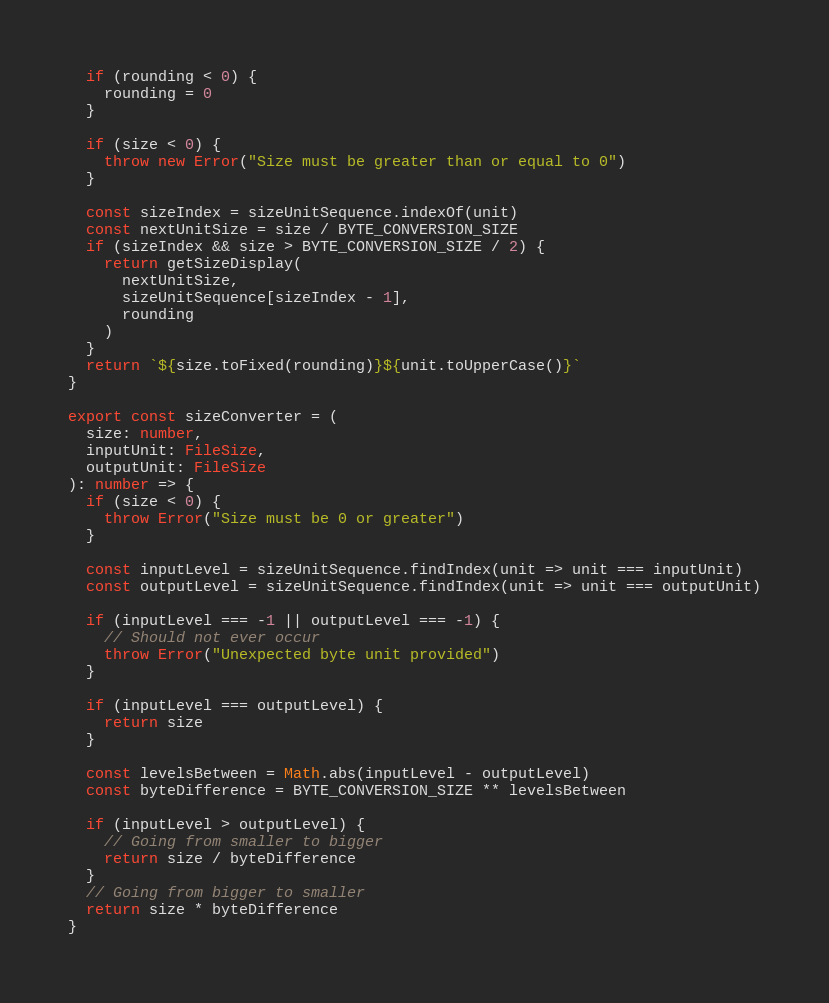<code> <loc_0><loc_0><loc_500><loc_500><_TypeScript_>
  if (rounding < 0) {
    rounding = 0
  }

  if (size < 0) {
    throw new Error("Size must be greater than or equal to 0")
  }

  const sizeIndex = sizeUnitSequence.indexOf(unit)
  const nextUnitSize = size / BYTE_CONVERSION_SIZE
  if (sizeIndex && size > BYTE_CONVERSION_SIZE / 2) {
    return getSizeDisplay(
      nextUnitSize,
      sizeUnitSequence[sizeIndex - 1],
      rounding
    )
  }
  return `${size.toFixed(rounding)}${unit.toUpperCase()}`
}

export const sizeConverter = (
  size: number,
  inputUnit: FileSize,
  outputUnit: FileSize
): number => {
  if (size < 0) {
    throw Error("Size must be 0 or greater")
  }

  const inputLevel = sizeUnitSequence.findIndex(unit => unit === inputUnit)
  const outputLevel = sizeUnitSequence.findIndex(unit => unit === outputUnit)

  if (inputLevel === -1 || outputLevel === -1) {
    // Should not ever occur
    throw Error("Unexpected byte unit provided")
  }

  if (inputLevel === outputLevel) {
    return size
  }

  const levelsBetween = Math.abs(inputLevel - outputLevel)
  const byteDifference = BYTE_CONVERSION_SIZE ** levelsBetween

  if (inputLevel > outputLevel) {
    // Going from smaller to bigger
    return size / byteDifference
  }
  // Going from bigger to smaller
  return size * byteDifference
}
</code> 